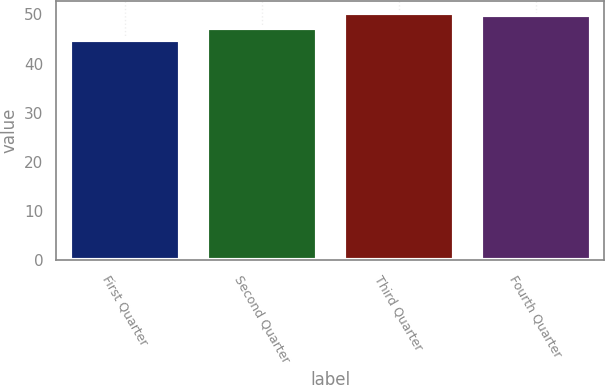<chart> <loc_0><loc_0><loc_500><loc_500><bar_chart><fcel>First Quarter<fcel>Second Quarter<fcel>Third Quarter<fcel>Fourth Quarter<nl><fcel>44.74<fcel>47.27<fcel>50.32<fcel>49.79<nl></chart> 